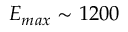Convert formula to latex. <formula><loc_0><loc_0><loc_500><loc_500>E _ { \max } \sim 1 2 0 0</formula> 